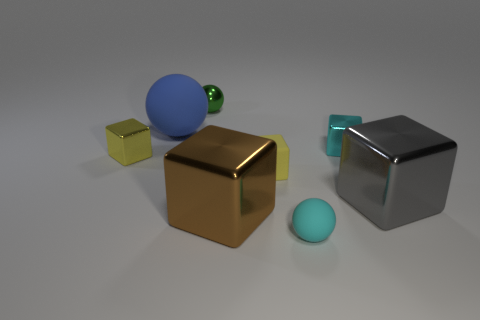Subtract all small matte balls. How many balls are left? 2 Subtract all green balls. How many balls are left? 2 Add 1 cubes. How many objects exist? 9 Subtract all spheres. How many objects are left? 5 Subtract all brown cylinders. How many green balls are left? 1 Subtract all blue matte things. Subtract all small blue objects. How many objects are left? 7 Add 4 cyan shiny blocks. How many cyan shiny blocks are left? 5 Add 4 balls. How many balls exist? 7 Subtract 1 green balls. How many objects are left? 7 Subtract 1 balls. How many balls are left? 2 